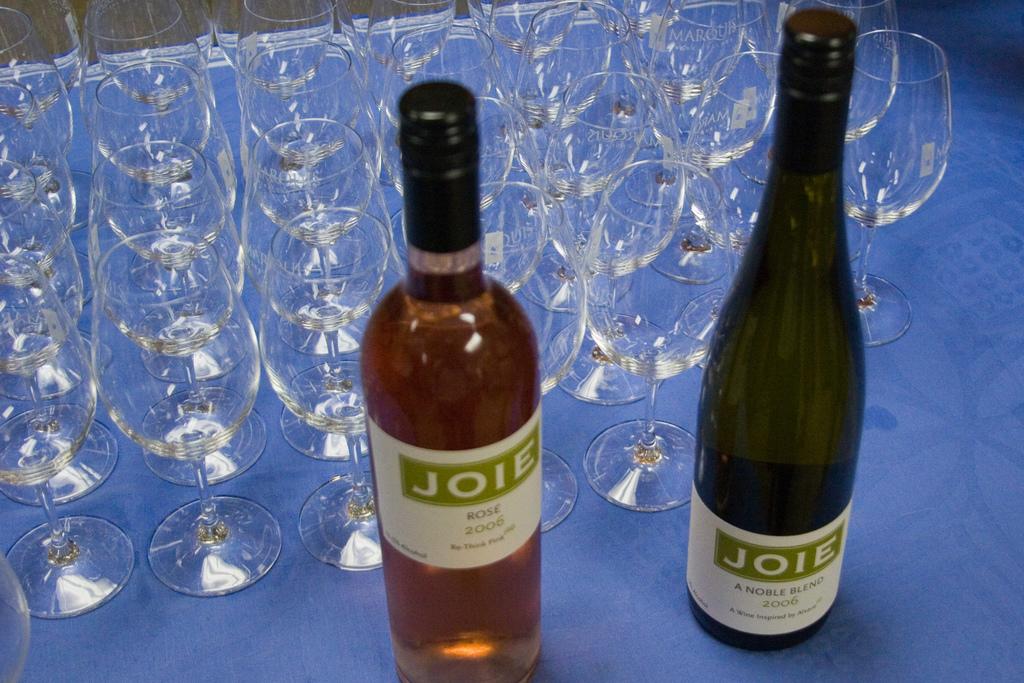What brand is the wine?
Keep it short and to the point. Joie. What kind of wine is in the left bottle?
Ensure brevity in your answer.  Rose. 